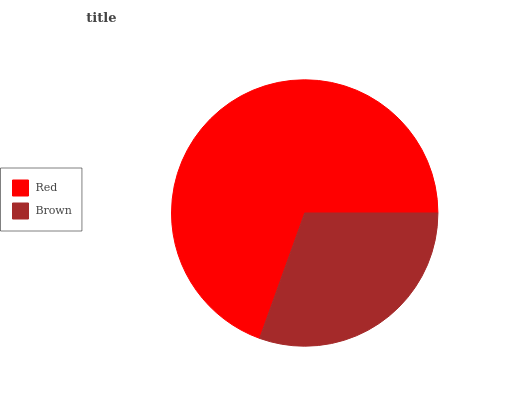Is Brown the minimum?
Answer yes or no. Yes. Is Red the maximum?
Answer yes or no. Yes. Is Brown the maximum?
Answer yes or no. No. Is Red greater than Brown?
Answer yes or no. Yes. Is Brown less than Red?
Answer yes or no. Yes. Is Brown greater than Red?
Answer yes or no. No. Is Red less than Brown?
Answer yes or no. No. Is Red the high median?
Answer yes or no. Yes. Is Brown the low median?
Answer yes or no. Yes. Is Brown the high median?
Answer yes or no. No. Is Red the low median?
Answer yes or no. No. 